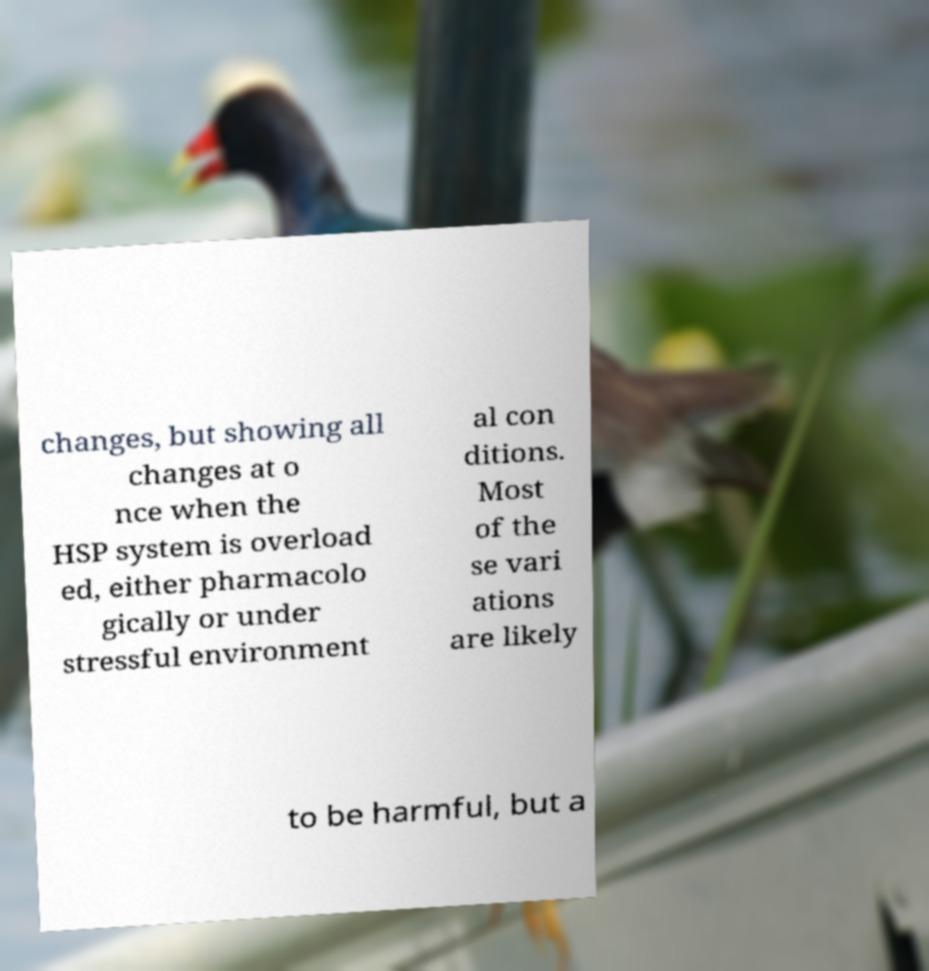I need the written content from this picture converted into text. Can you do that? changes, but showing all changes at o nce when the HSP system is overload ed, either pharmacolo gically or under stressful environment al con ditions. Most of the se vari ations are likely to be harmful, but a 